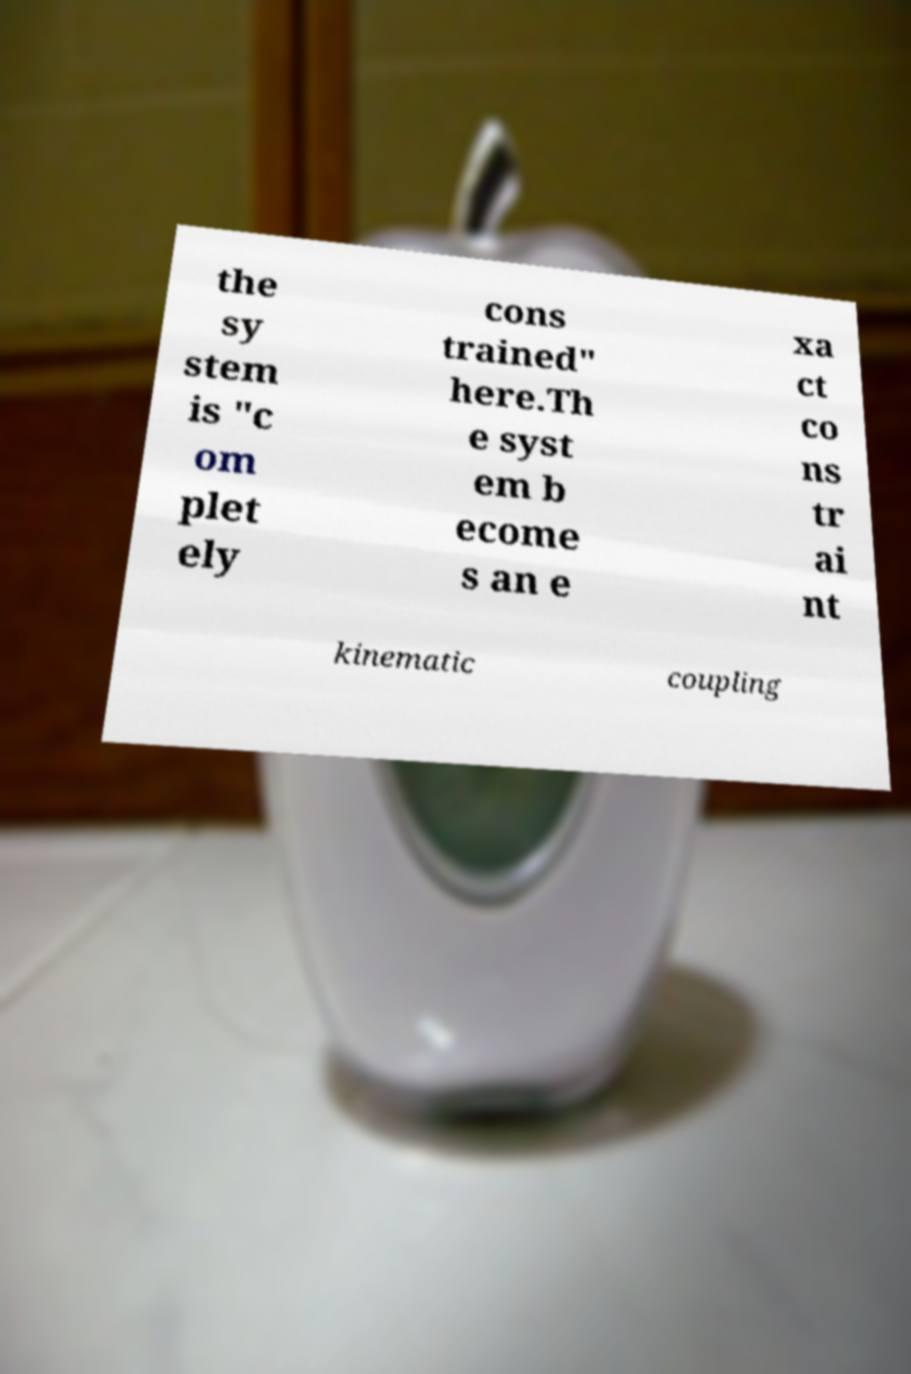There's text embedded in this image that I need extracted. Can you transcribe it verbatim? the sy stem is "c om plet ely cons trained" here.Th e syst em b ecome s an e xa ct co ns tr ai nt kinematic coupling 